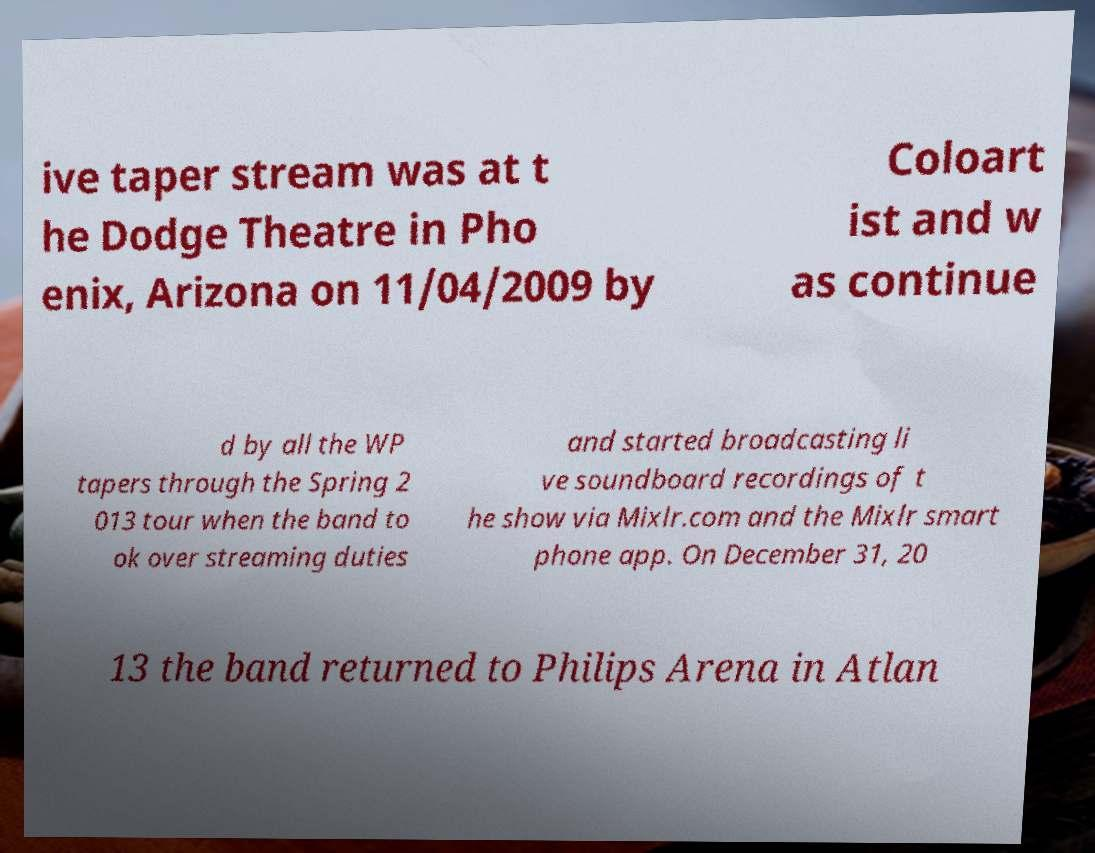I need the written content from this picture converted into text. Can you do that? ive taper stream was at t he Dodge Theatre in Pho enix, Arizona on 11/04/2009 by Coloart ist and w as continue d by all the WP tapers through the Spring 2 013 tour when the band to ok over streaming duties and started broadcasting li ve soundboard recordings of t he show via Mixlr.com and the Mixlr smart phone app. On December 31, 20 13 the band returned to Philips Arena in Atlan 